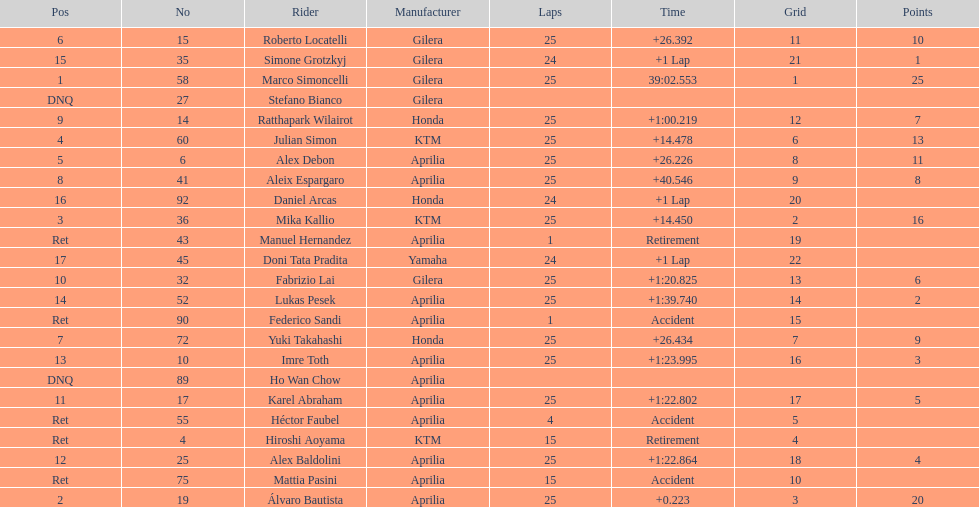Did marco simoncelli or alvaro bautista held rank 1? Marco Simoncelli. 